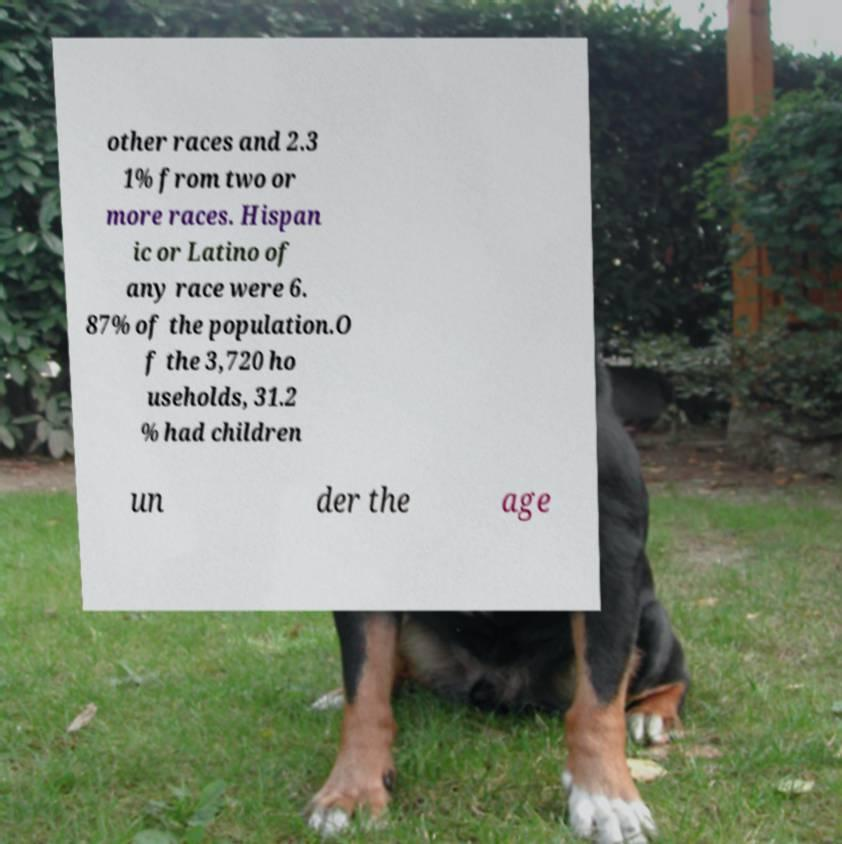Can you accurately transcribe the text from the provided image for me? other races and 2.3 1% from two or more races. Hispan ic or Latino of any race were 6. 87% of the population.O f the 3,720 ho useholds, 31.2 % had children un der the age 